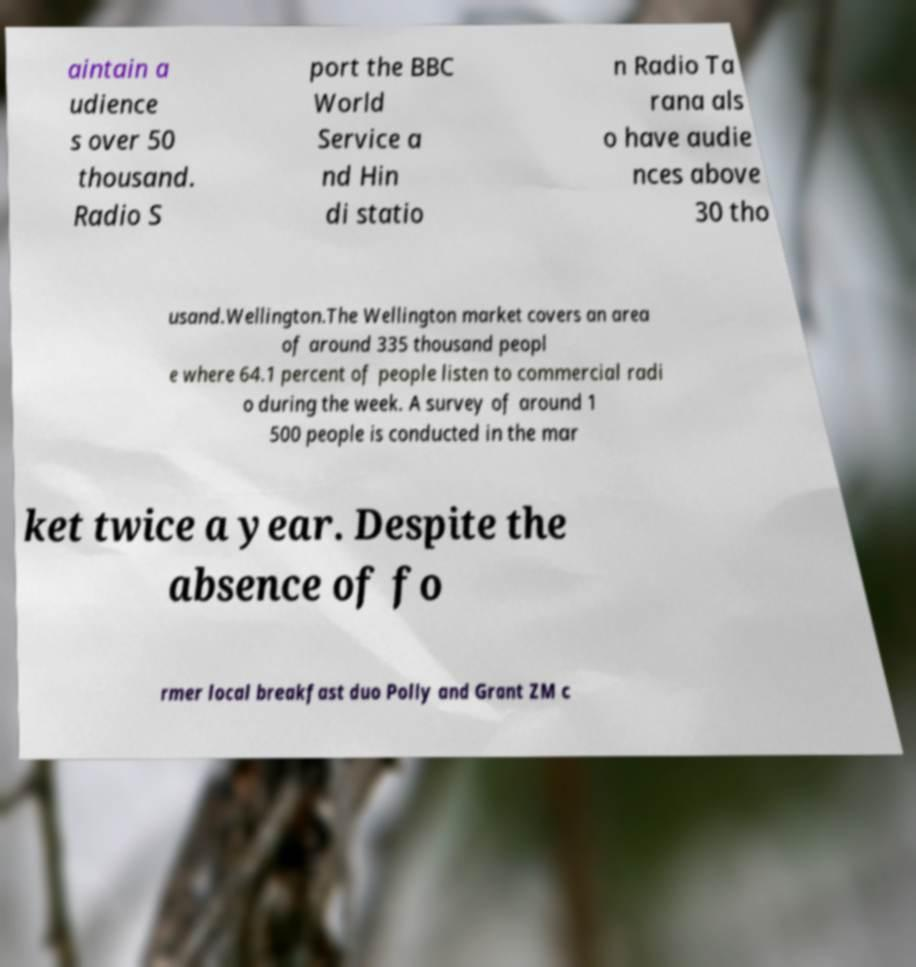Can you read and provide the text displayed in the image?This photo seems to have some interesting text. Can you extract and type it out for me? aintain a udience s over 50 thousand. Radio S port the BBC World Service a nd Hin di statio n Radio Ta rana als o have audie nces above 30 tho usand.Wellington.The Wellington market covers an area of around 335 thousand peopl e where 64.1 percent of people listen to commercial radi o during the week. A survey of around 1 500 people is conducted in the mar ket twice a year. Despite the absence of fo rmer local breakfast duo Polly and Grant ZM c 